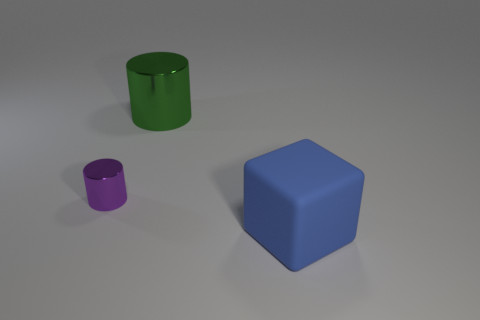Are there any other things that are the same size as the purple metallic object?
Provide a short and direct response. No. Are there any other things that are the same material as the large cube?
Your response must be concise. No. There is a large blue object; are there any large green things on the right side of it?
Your response must be concise. No. Is the number of large green things that are in front of the big blue block greater than the number of yellow cubes?
Your answer should be compact. No. Are there any big things of the same color as the tiny shiny thing?
Make the answer very short. No. There is a metallic cylinder that is the same size as the blue rubber thing; what color is it?
Your answer should be very brief. Green. There is a big thing that is on the left side of the blue rubber thing; is there a blue matte block that is in front of it?
Make the answer very short. Yes. There is a large thing that is to the left of the blue block; what material is it?
Provide a succinct answer. Metal. Do the large thing that is behind the cube and the object in front of the purple thing have the same material?
Offer a terse response. No. Is the number of blue rubber cubes on the left side of the large metal cylinder the same as the number of tiny shiny cylinders that are to the left of the small metallic object?
Offer a terse response. Yes. 